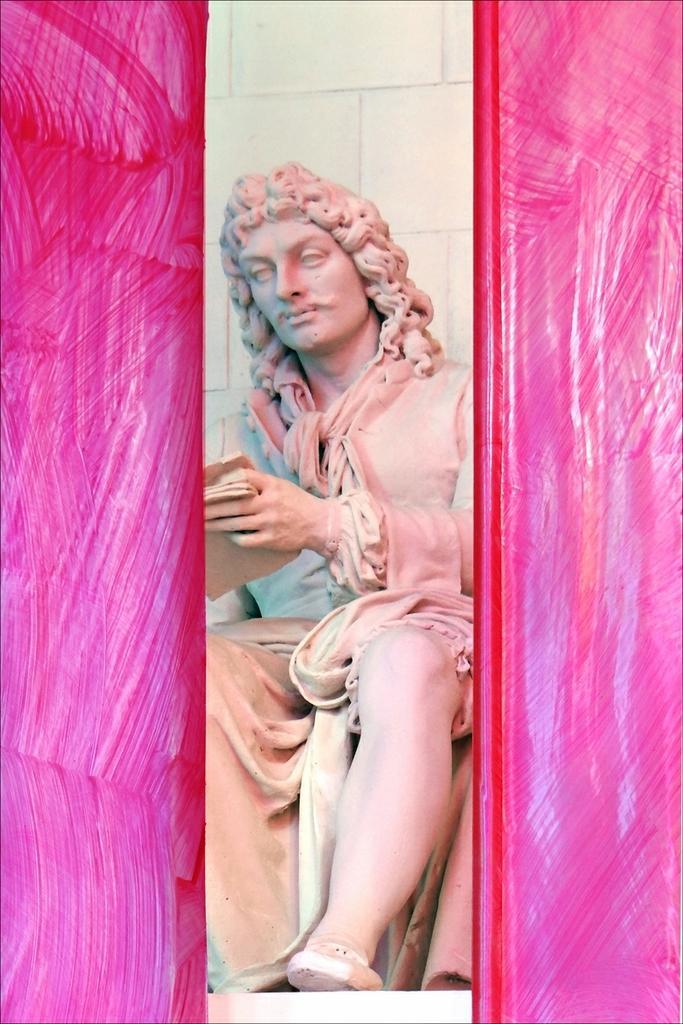How would you summarize this image in a sentence or two? In this image we can see a sculpture. Left side of the image and right side of the image it is in pink color. 